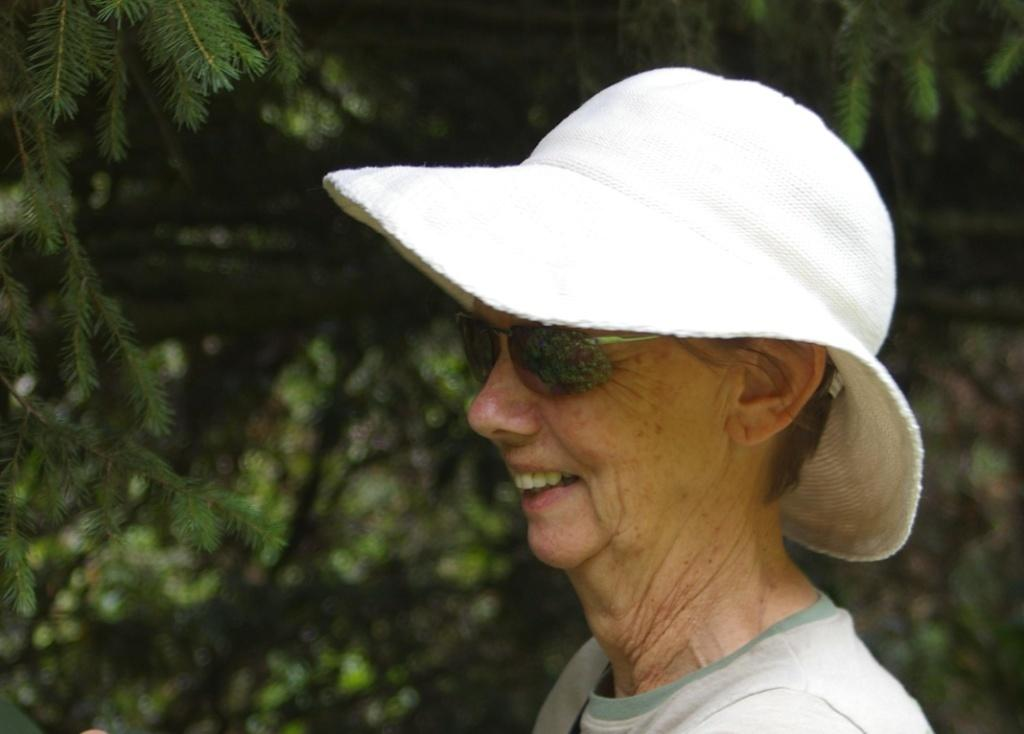Who or what is the main subject in the picture? There is a person in the picture. Can you describe the person's attire? The person is wearing a white hat. What accessory is the person wearing? The person is wearing spectacles. How would you describe the background of the image? The background of the image is blurred. How many horses are visible in the image? There are no horses present in the image. What type of clam is being exchanged between the person and another individual in the image? There is no exchange of clams or any other items visible in the image. 